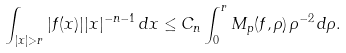Convert formula to latex. <formula><loc_0><loc_0><loc_500><loc_500>\int _ { | x | > r } | f ( x ) | | x | ^ { - n - 1 } \, d x \leq C _ { n } \int _ { 0 } ^ { r } M _ { p } ( f , \rho ) \, \rho ^ { - 2 } \, d \rho .</formula> 